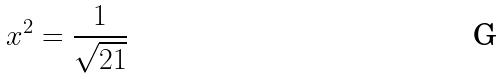Convert formula to latex. <formula><loc_0><loc_0><loc_500><loc_500>x ^ { 2 } = \frac { 1 } { \sqrt { 2 1 } }</formula> 